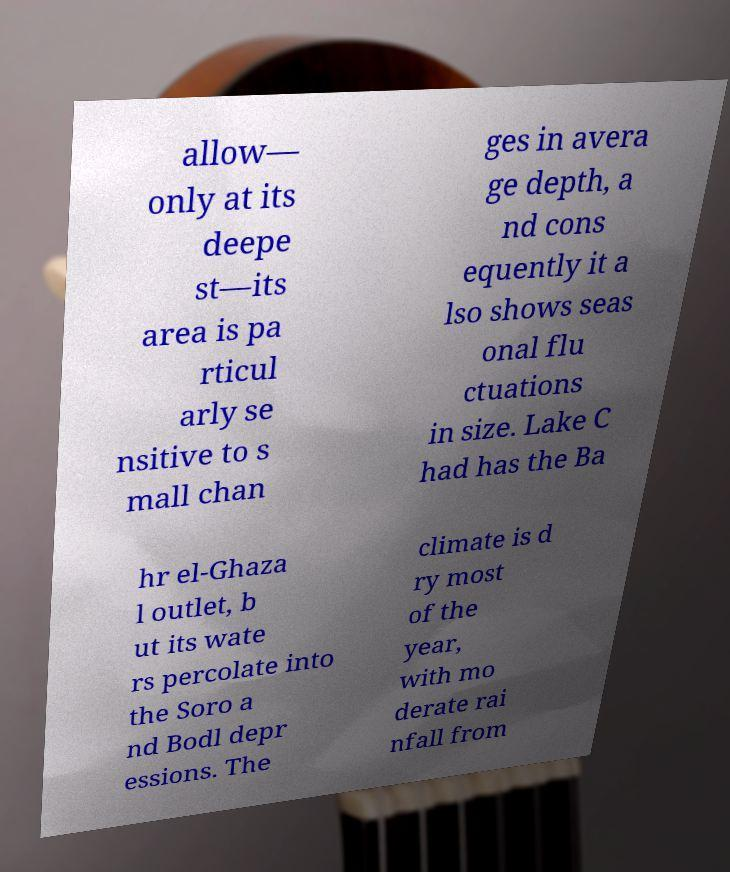Please identify and transcribe the text found in this image. allow— only at its deepe st—its area is pa rticul arly se nsitive to s mall chan ges in avera ge depth, a nd cons equently it a lso shows seas onal flu ctuations in size. Lake C had has the Ba hr el-Ghaza l outlet, b ut its wate rs percolate into the Soro a nd Bodl depr essions. The climate is d ry most of the year, with mo derate rai nfall from 